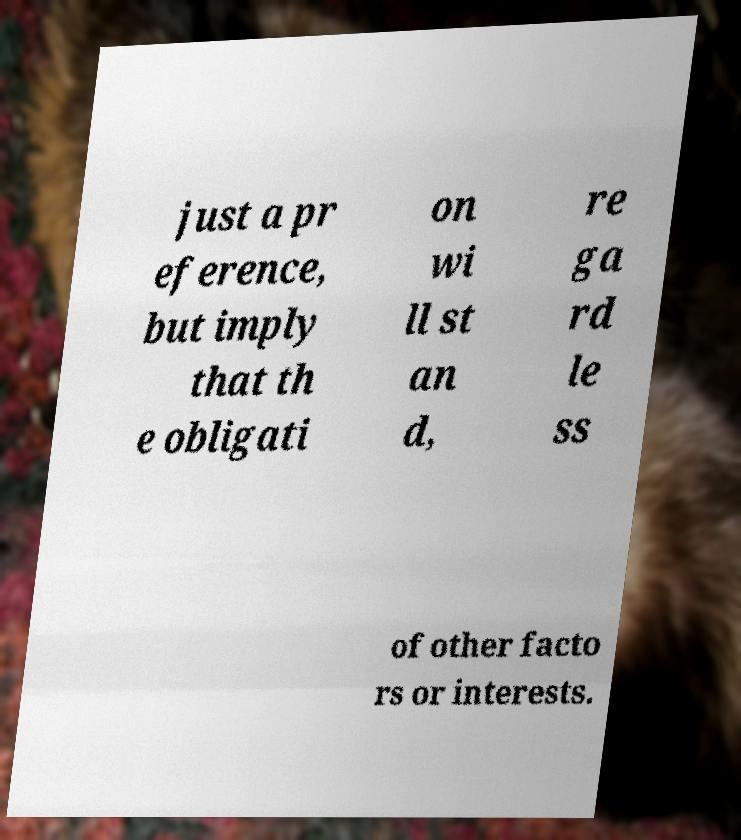I need the written content from this picture converted into text. Can you do that? just a pr eference, but imply that th e obligati on wi ll st an d, re ga rd le ss of other facto rs or interests. 